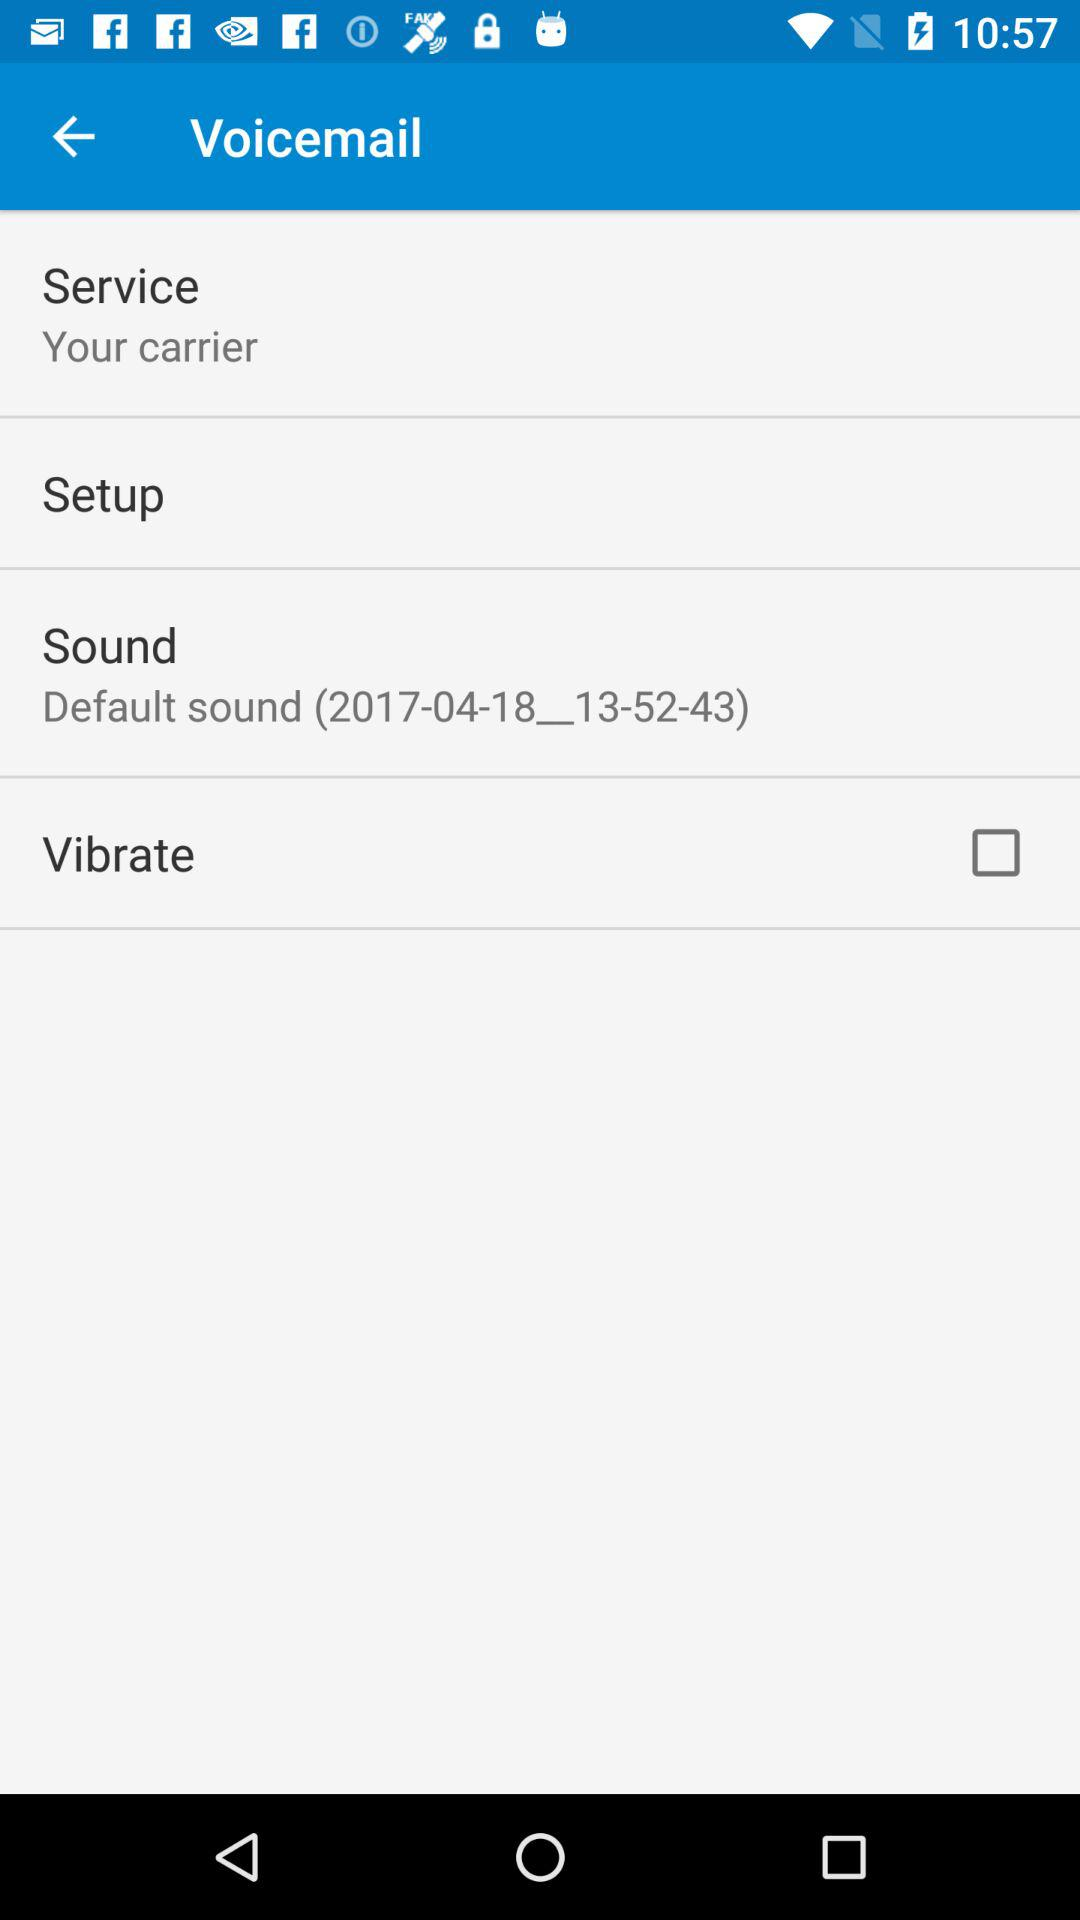Which sound is set for voicemail? The sound set for voicemail is "Default sound (2017-04-18__13-52-43)". 